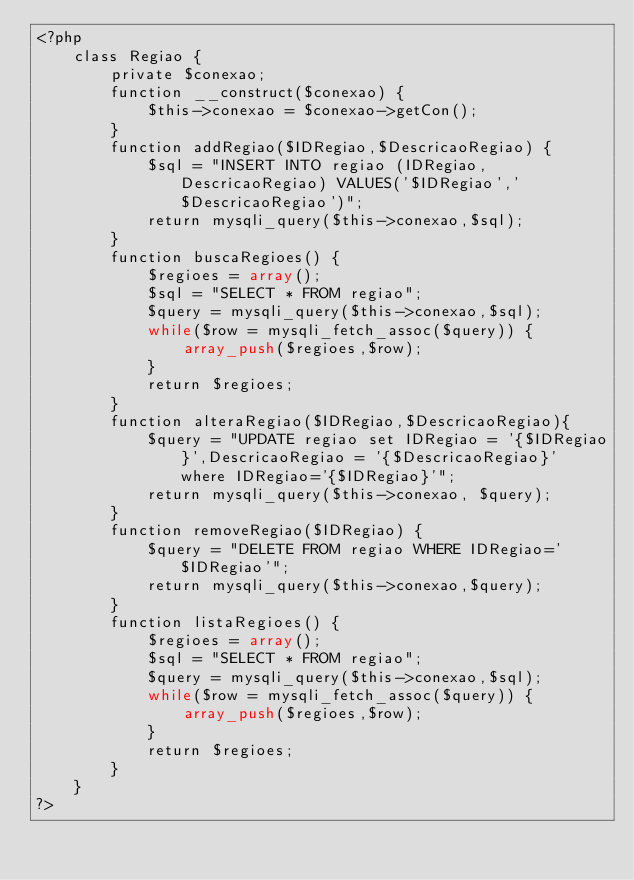Convert code to text. <code><loc_0><loc_0><loc_500><loc_500><_PHP_><?php
    class Regiao {
        private $conexao;
        function __construct($conexao) {
            $this->conexao = $conexao->getCon();
        }
        function addRegiao($IDRegiao,$DescricaoRegiao) {
            $sql = "INSERT INTO regiao (IDRegiao,DescricaoRegiao) VALUES('$IDRegiao','$DescricaoRegiao')";
            return mysqli_query($this->conexao,$sql);
        }
        function buscaRegioes() {
            $regioes = array();
            $sql = "SELECT * FROM regiao";
            $query = mysqli_query($this->conexao,$sql);
            while($row = mysqli_fetch_assoc($query)) {
                array_push($regioes,$row);
            }
            return $regioes;
        }
        function alteraRegiao($IDRegiao,$DescricaoRegiao){
            $query = "UPDATE regiao set IDRegiao = '{$IDRegiao}',DescricaoRegiao = '{$DescricaoRegiao}' where IDRegiao='{$IDRegiao}'";
            return mysqli_query($this->conexao, $query);
        }
        function removeRegiao($IDRegiao) {
            $query = "DELETE FROM regiao WHERE IDRegiao='$IDRegiao'";
            return mysqli_query($this->conexao,$query);
        }
        function listaRegioes() {
            $regioes = array();
            $sql = "SELECT * FROM regiao";
            $query = mysqli_query($this->conexao,$sql);
            while($row = mysqli_fetch_assoc($query)) {
                array_push($regioes,$row);
            }
            return $regioes;
        }
    }
?></code> 